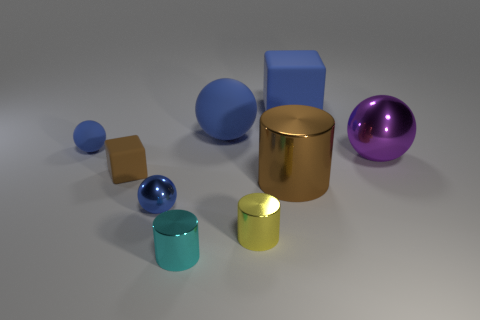There is a large thing that is both behind the tiny cube and left of the big blue block; what color is it?
Offer a terse response. Blue. What number of blue matte cubes are the same size as the yellow metal cylinder?
Your answer should be compact. 0. There is a metallic object on the right side of the large metallic thing that is in front of the small brown rubber object; what is its shape?
Provide a short and direct response. Sphere. The object that is in front of the small yellow thing in front of the metallic ball in front of the large purple sphere is what shape?
Provide a short and direct response. Cylinder. How many yellow objects have the same shape as the tiny brown matte thing?
Offer a very short reply. 0. There is a large thing that is on the left side of the yellow metallic object; how many blue rubber things are left of it?
Ensure brevity in your answer.  1. How many matte things are big brown cylinders or big blue things?
Your answer should be compact. 2. Is there a purple sphere that has the same material as the tiny yellow cylinder?
Offer a terse response. Yes. How many objects are tiny things behind the small cyan object or blue objects behind the big purple metallic ball?
Keep it short and to the point. 6. Is the color of the tiny sphere in front of the brown rubber object the same as the big rubber block?
Provide a short and direct response. Yes. 